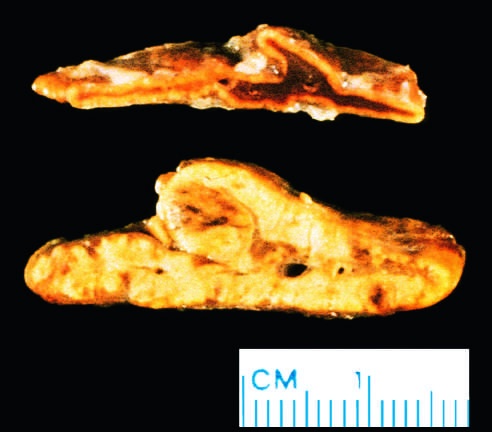s a subtle nodularity evident?
Answer the question using a single word or phrase. Yes 